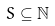Convert formula to latex. <formula><loc_0><loc_0><loc_500><loc_500>S \subseteq \mathbb { N }</formula> 